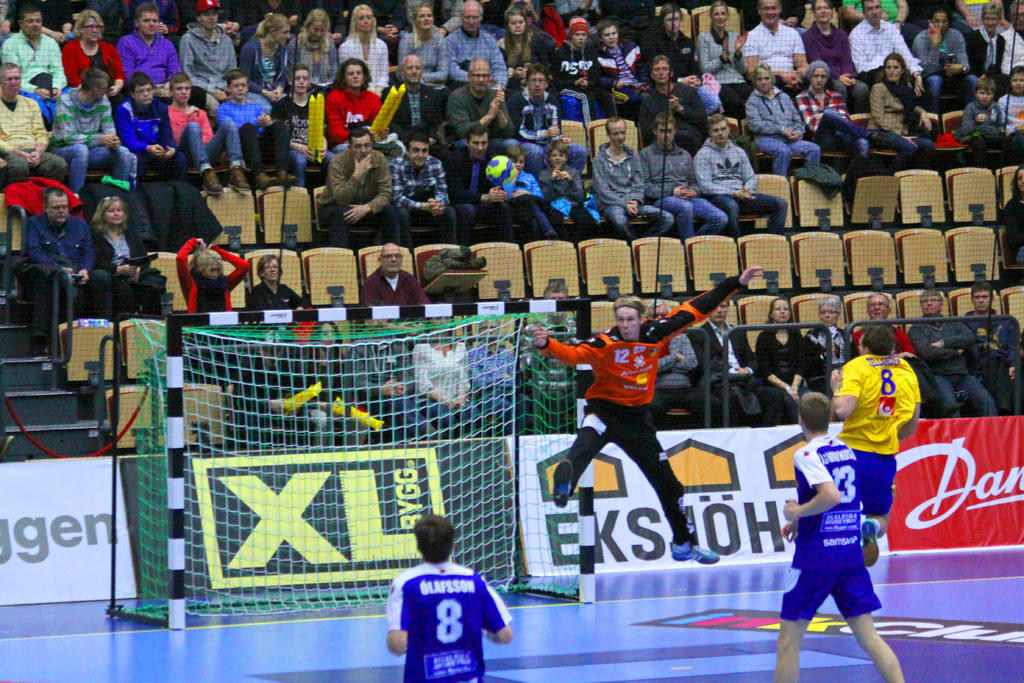Describe the atmosphere in the image. The atmosphere appears lively and intense, with a crowd of spectators watching a critical moment as a player takes a shot on goal. 